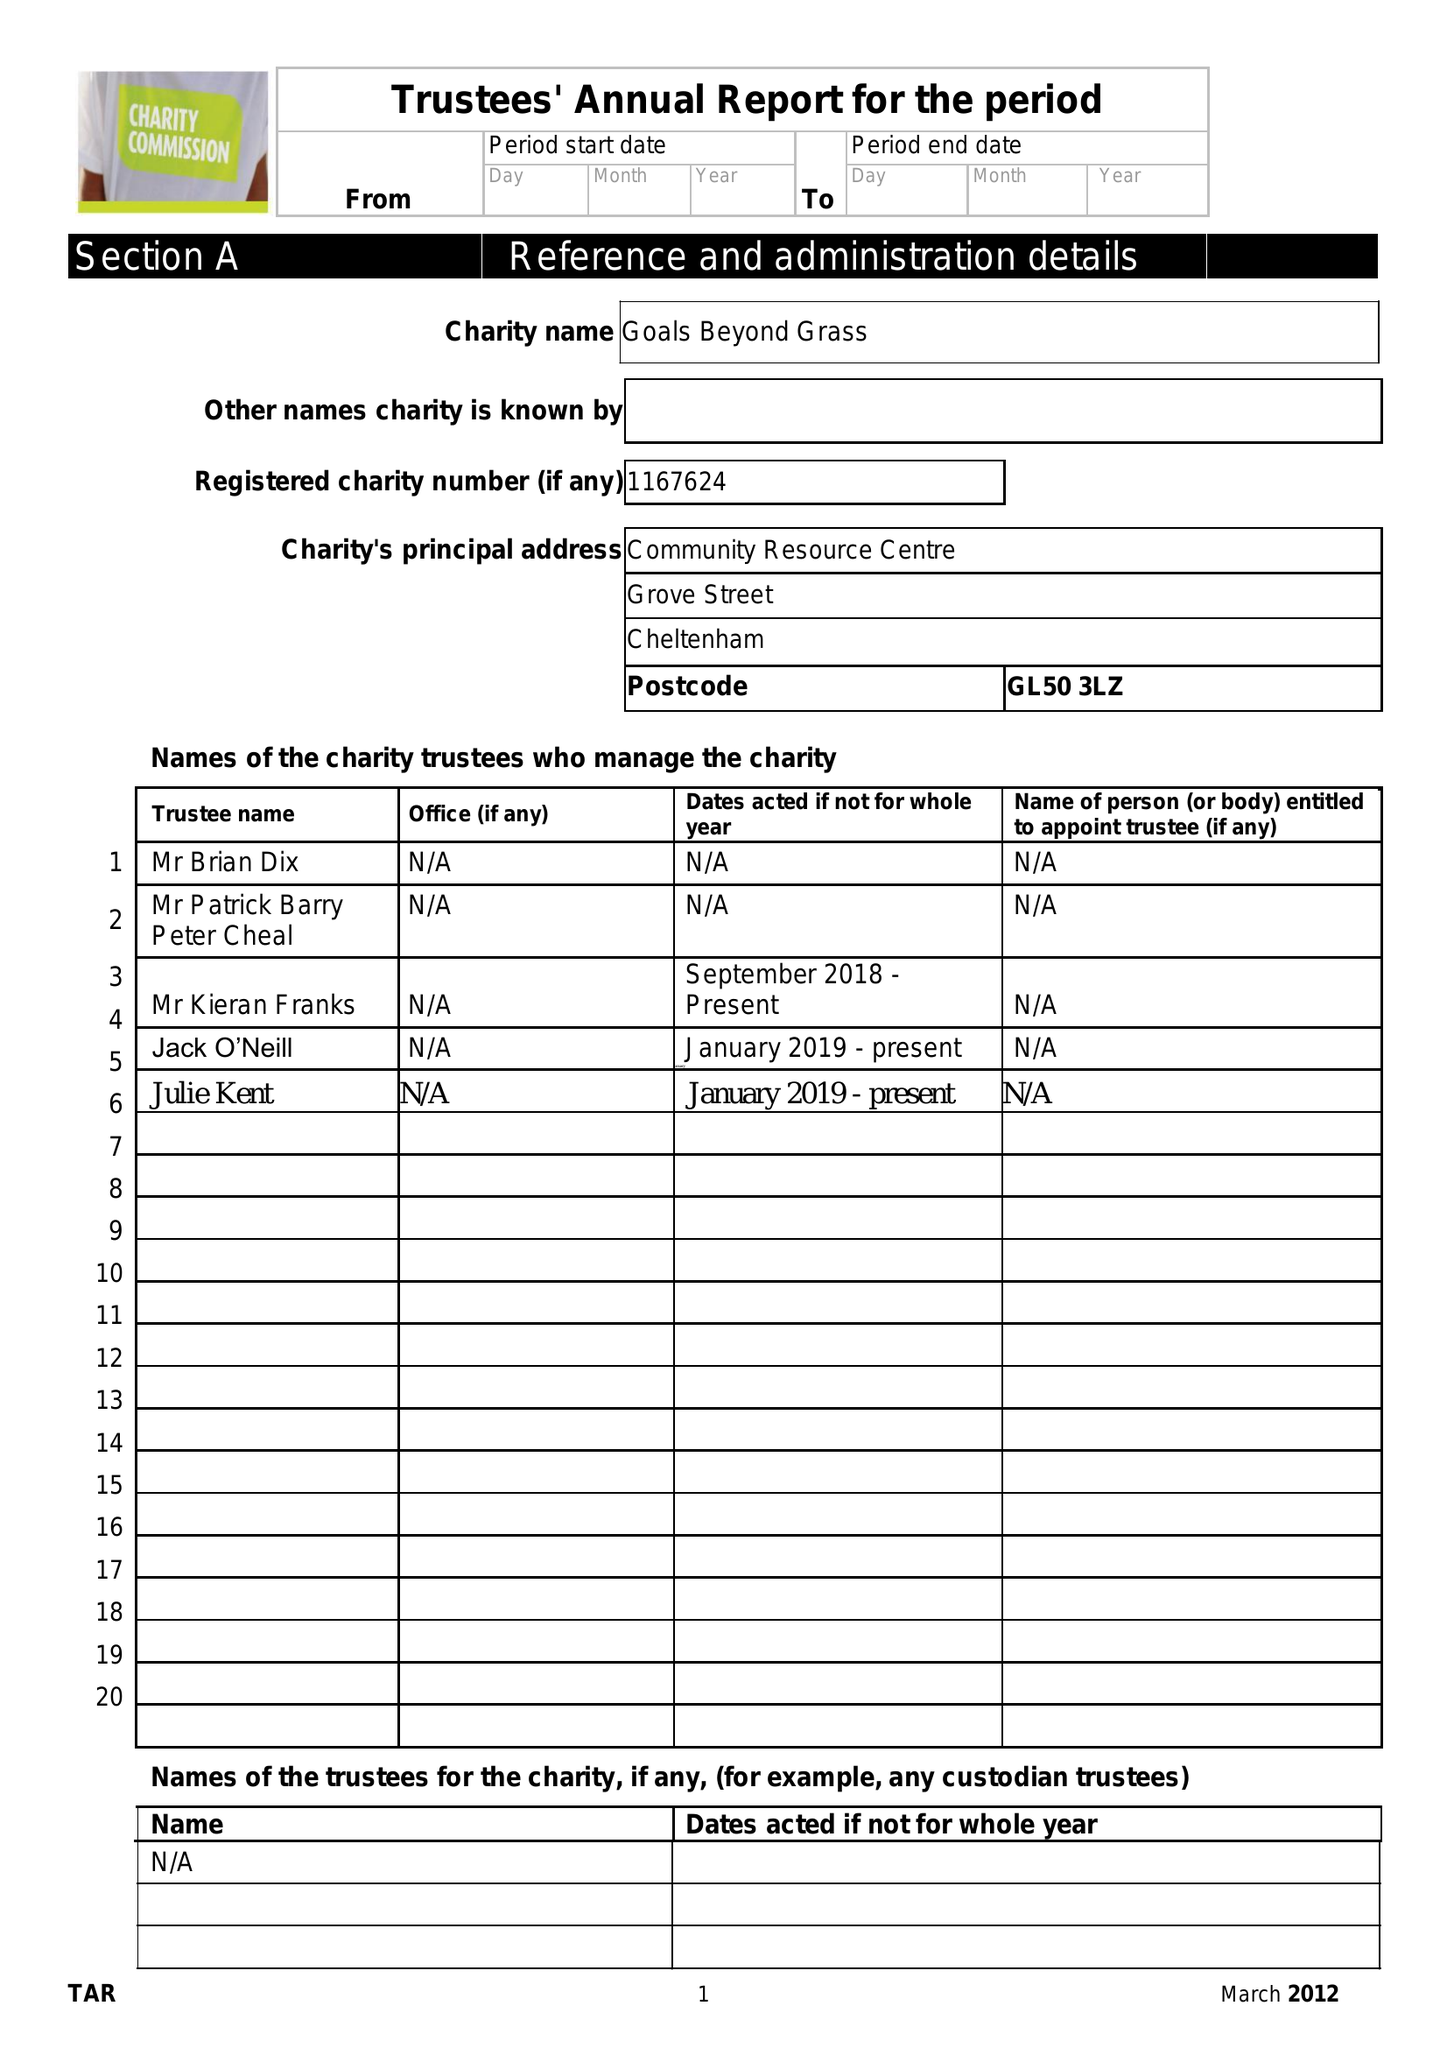What is the value for the income_annually_in_british_pounds?
Answer the question using a single word or phrase. 102412.86 